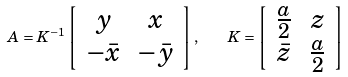Convert formula to latex. <formula><loc_0><loc_0><loc_500><loc_500>A = K ^ { - 1 } \left [ \begin{array} { c c } y & x \\ - \bar { x } & - \bar { y } \end{array} \right ] , \quad K = \left [ \begin{array} { c c } \frac { a } { 2 } & z \\ \bar { z } & \frac { a } { 2 } \end{array} \right ]</formula> 